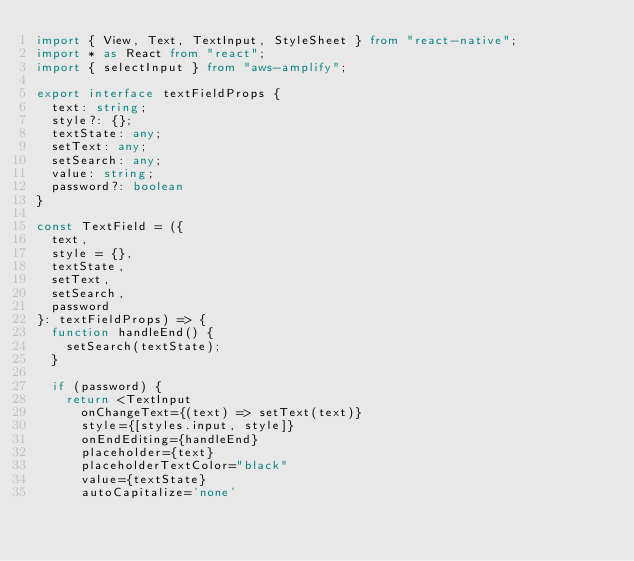<code> <loc_0><loc_0><loc_500><loc_500><_TypeScript_>import { View, Text, TextInput, StyleSheet } from "react-native";
import * as React from "react";
import { selectInput } from "aws-amplify";

export interface textFieldProps {
  text: string;
  style?: {};
  textState: any;
  setText: any;
  setSearch: any;
  value: string;
  password?: boolean
}

const TextField = ({
  text,
  style = {},
  textState,
  setText,
  setSearch,
  password
}: textFieldProps) => {
  function handleEnd() {
    setSearch(textState);
  }

  if (password) {
    return <TextInput
      onChangeText={(text) => setText(text)}
      style={[styles.input, style]}
      onEndEditing={handleEnd}
      placeholder={text}
      placeholderTextColor="black"
      value={textState}
      autoCapitalize='none'</code> 